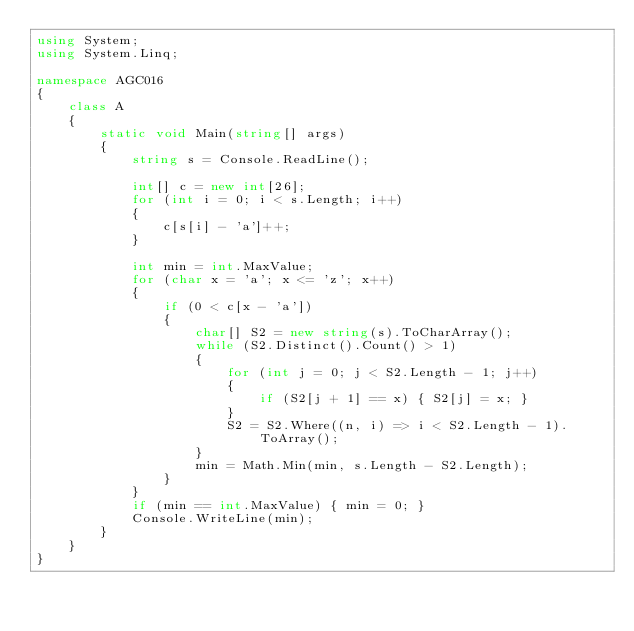Convert code to text. <code><loc_0><loc_0><loc_500><loc_500><_C#_>using System;
using System.Linq;

namespace AGC016
{
    class A
    {
        static void Main(string[] args)
        {
            string s = Console.ReadLine();

            int[] c = new int[26];
            for (int i = 0; i < s.Length; i++)
            {
                c[s[i] - 'a']++;
            }

            int min = int.MaxValue;
            for (char x = 'a'; x <= 'z'; x++)
            {
                if (0 < c[x - 'a'])
                {
                    char[] S2 = new string(s).ToCharArray();
                    while (S2.Distinct().Count() > 1)
                    {
                        for (int j = 0; j < S2.Length - 1; j++)
                        {
                            if (S2[j + 1] == x) { S2[j] = x; }
                        }
                        S2 = S2.Where((n, i) => i < S2.Length - 1).ToArray();
                    }
                    min = Math.Min(min, s.Length - S2.Length);
                }
            }
            if (min == int.MaxValue) { min = 0; }
            Console.WriteLine(min);
        }
    }
}
</code> 